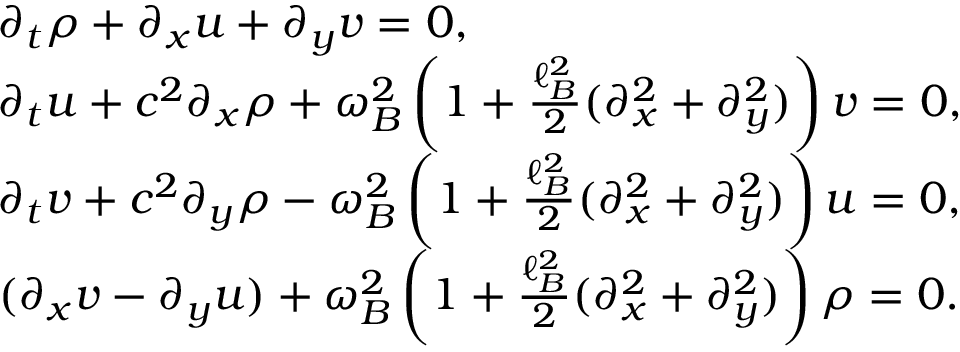<formula> <loc_0><loc_0><loc_500><loc_500>\begin{array} { r l } & { \partial _ { t } \rho + \partial _ { x } u + \partial _ { y } v = 0 , } \\ & { \partial _ { t } u + c ^ { 2 } \partial _ { x } \rho + \omega _ { B } ^ { 2 } \left ( 1 + \frac { \ell _ { B } ^ { 2 } } { 2 } ( \partial _ { x } ^ { 2 } + \partial _ { y } ^ { 2 } ) \right ) v = 0 , } \\ & { \partial _ { t } v + c ^ { 2 } \partial _ { y } \rho - \omega _ { B } ^ { 2 } \left ( 1 + \frac { \ell _ { B } ^ { 2 } } { 2 } ( \partial _ { x } ^ { 2 } + \partial _ { y } ^ { 2 } ) \right ) u = 0 , } \\ & { ( \partial _ { x } v - \partial _ { y } u ) + \omega _ { B } ^ { 2 } \left ( 1 + \frac { \ell _ { B } ^ { 2 } } { 2 } ( \partial _ { x } ^ { 2 } + \partial _ { y } ^ { 2 } ) \right ) \rho = 0 . } \end{array}</formula> 